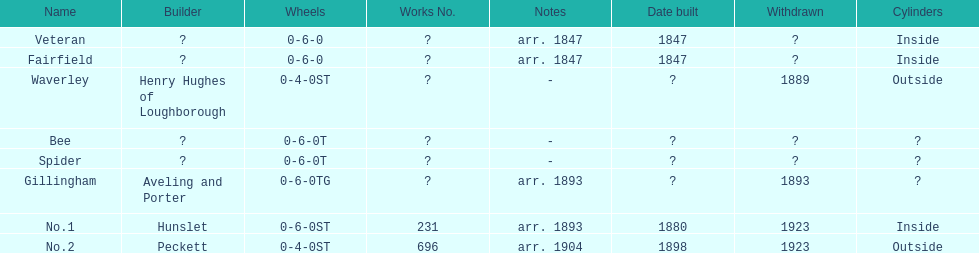How long after fairfield was no. 1 built? 33 years. 